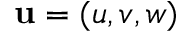<formula> <loc_0><loc_0><loc_500><loc_500>\mathbf u = ( u , v , w )</formula> 